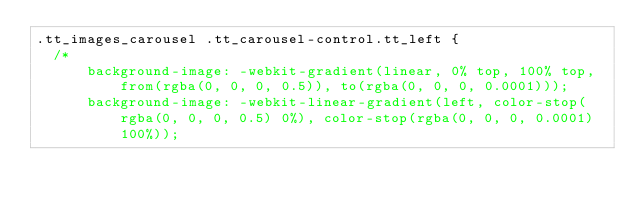<code> <loc_0><loc_0><loc_500><loc_500><_CSS_>.tt_images_carousel .tt_carousel-control.tt_left {
  /*
      background-image: -webkit-gradient(linear, 0% top, 100% top, from(rgba(0, 0, 0, 0.5)), to(rgba(0, 0, 0, 0.0001)));
      background-image: -webkit-linear-gradient(left, color-stop(rgba(0, 0, 0, 0.5) 0%), color-stop(rgba(0, 0, 0, 0.0001) 100%));</code> 